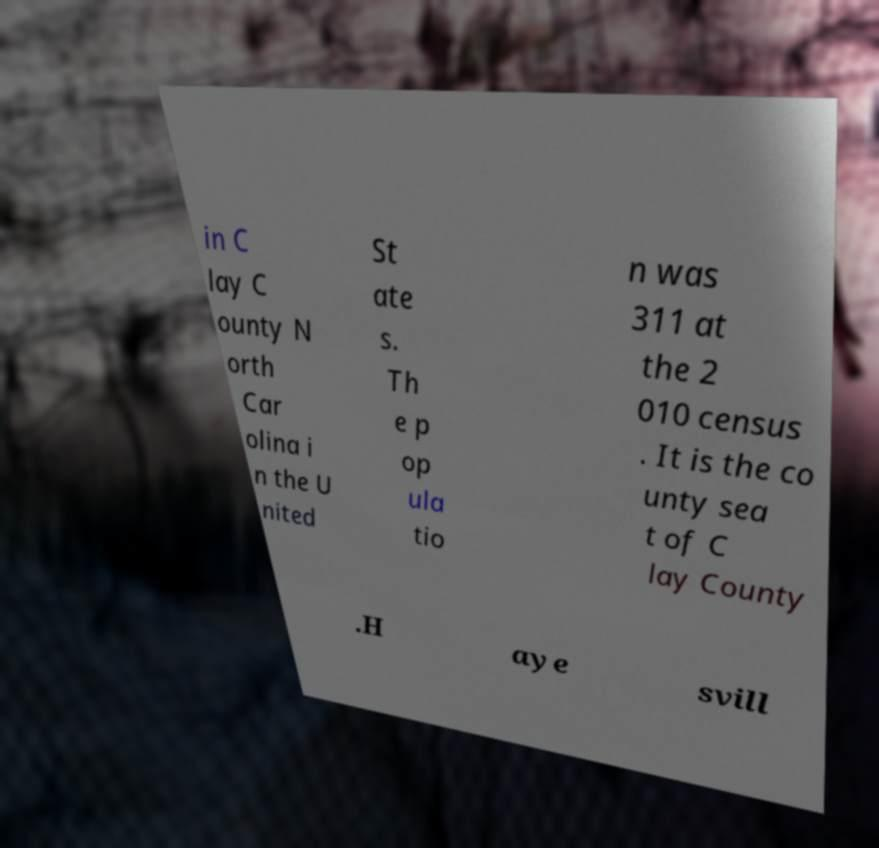Could you extract and type out the text from this image? in C lay C ounty N orth Car olina i n the U nited St ate s. Th e p op ula tio n was 311 at the 2 010 census . It is the co unty sea t of C lay County .H aye svill 